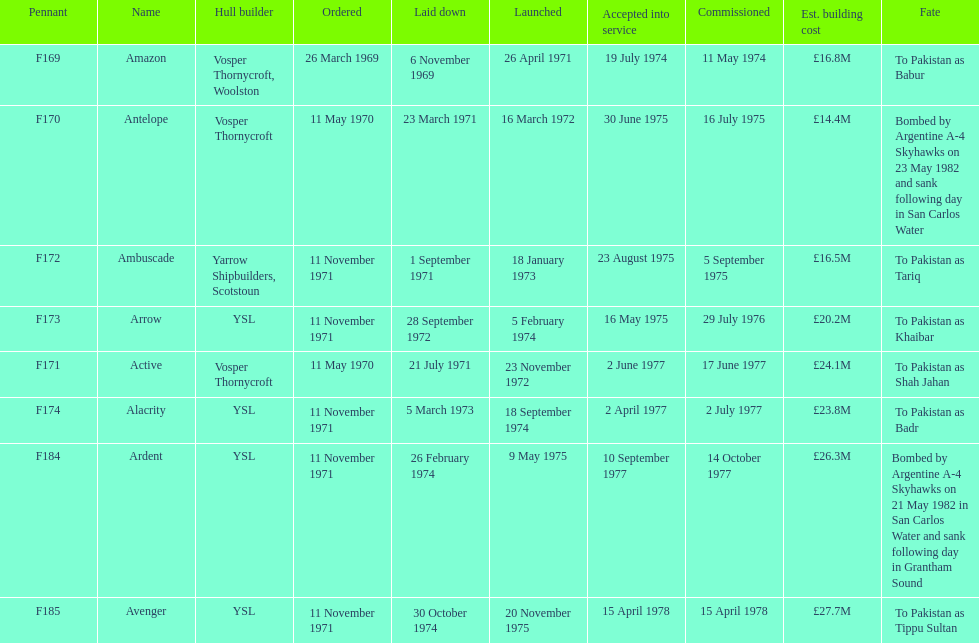I'm looking to parse the entire table for insights. Could you assist me with that? {'header': ['Pennant', 'Name', 'Hull builder', 'Ordered', 'Laid down', 'Launched', 'Accepted into service', 'Commissioned', 'Est. building cost', 'Fate'], 'rows': [['F169', 'Amazon', 'Vosper Thornycroft, Woolston', '26 March 1969', '6 November 1969', '26 April 1971', '19 July 1974', '11 May 1974', '£16.8M', 'To Pakistan as Babur'], ['F170', 'Antelope', 'Vosper Thornycroft', '11 May 1970', '23 March 1971', '16 March 1972', '30 June 1975', '16 July 1975', '£14.4M', 'Bombed by Argentine A-4 Skyhawks on 23 May 1982 and sank following day in San Carlos Water'], ['F172', 'Ambuscade', 'Yarrow Shipbuilders, Scotstoun', '11 November 1971', '1 September 1971', '18 January 1973', '23 August 1975', '5 September 1975', '£16.5M', 'To Pakistan as Tariq'], ['F173', 'Arrow', 'YSL', '11 November 1971', '28 September 1972', '5 February 1974', '16 May 1975', '29 July 1976', '£20.2M', 'To Pakistan as Khaibar'], ['F171', 'Active', 'Vosper Thornycroft', '11 May 1970', '21 July 1971', '23 November 1972', '2 June 1977', '17 June 1977', '£24.1M', 'To Pakistan as Shah Jahan'], ['F174', 'Alacrity', 'YSL', '11 November 1971', '5 March 1973', '18 September 1974', '2 April 1977', '2 July 1977', '£23.8M', 'To Pakistan as Badr'], ['F184', 'Ardent', 'YSL', '11 November 1971', '26 February 1974', '9 May 1975', '10 September 1977', '14 October 1977', '£26.3M', 'Bombed by Argentine A-4 Skyhawks on 21 May 1982 in San Carlos Water and sank following day in Grantham Sound'], ['F185', 'Avenger', 'YSL', '11 November 1971', '30 October 1974', '20 November 1975', '15 April 1978', '15 April 1978', '£27.7M', 'To Pakistan as Tippu Sultan']]} What is the ultimate listed pennant? F185. 